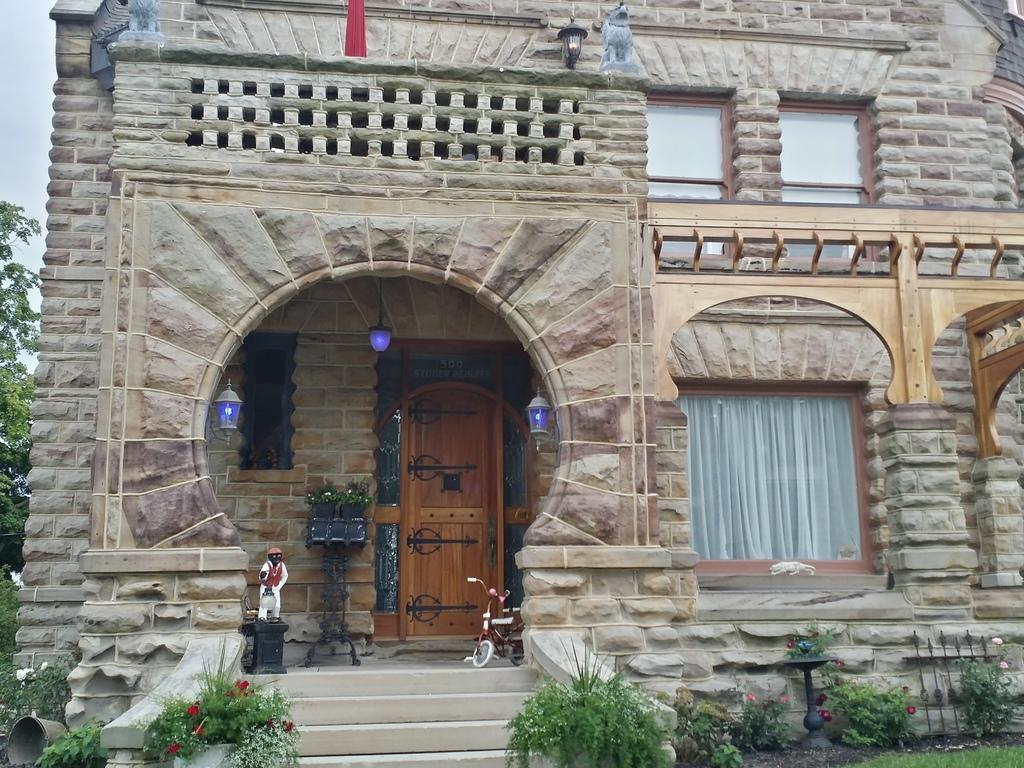What type of structure is visible in the image? There is a building in the image. What is a feature of the building that can be seen in the image? There is a door in the image. Are there any decorative elements in the image? Yes, there is a statue in the image. What type of window treatment is present in the image? There is a curtain in the image. What type of natural environment is visible in the image? There is grass and plants in the image. Are there any architectural features in the image? Yes, there are stairs in the image. What type of vegetation is visible in the image? There are trees in the image. What is visible at the top of the image? The sky is visible at the top of the image. What is the income of the person who owns the brain in the image? There is no brain or person's income mentioned in the image. 